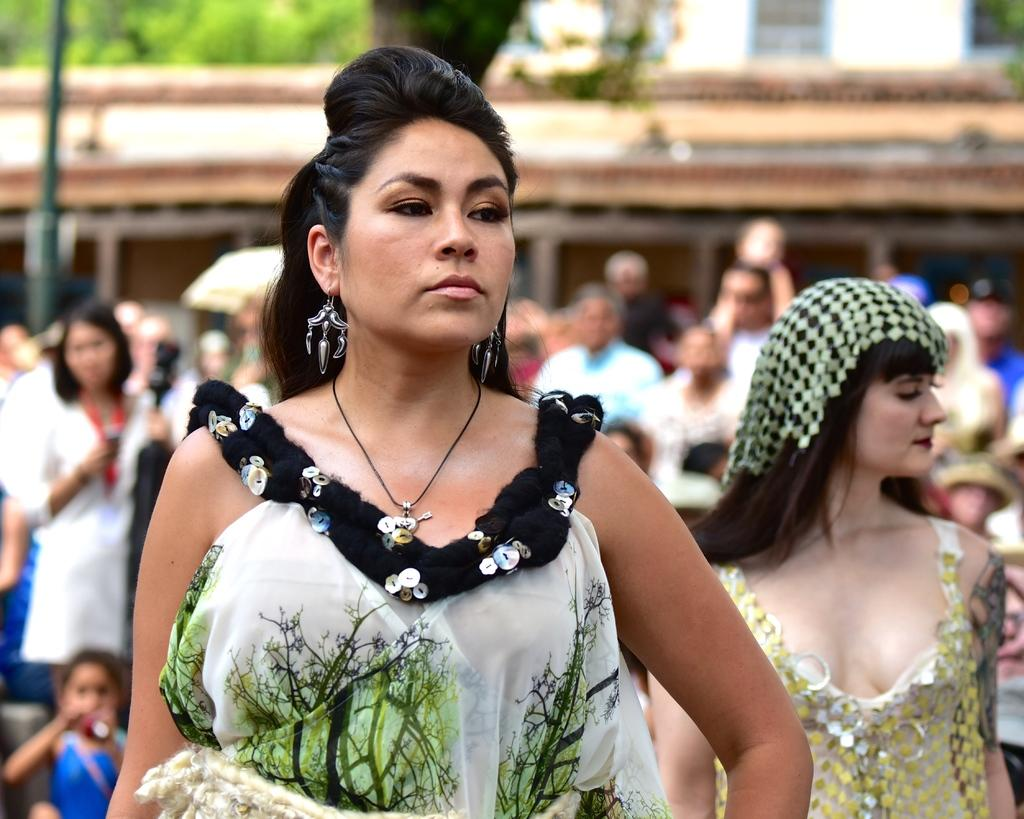How many people are in the group visible in the image? The number of people in the group cannot be determined from the provided facts. What type of structure is visible at the top of the image? There is a building visible at the top of the image. What type of plant is present in the image? There is a tree in the image. What vertical object can be seen in the image? There is a pole in the image. What type of scarf is being used as a drum in the image? There is no scarf or drum present in the image. What type of meal is being prepared by the group in the image? There is no meal preparation or consumption depicted in the image. 